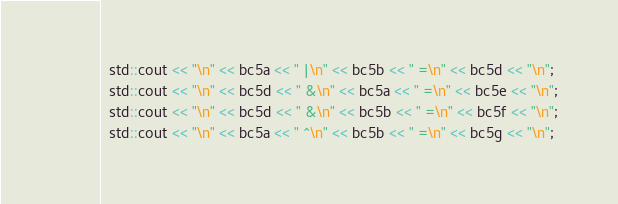Convert code to text. <code><loc_0><loc_0><loc_500><loc_500><_C++_>  std::cout << "\n" << bc5a << " |\n" << bc5b << " =\n" << bc5d << "\n";
  std::cout << "\n" << bc5d << " &\n" << bc5a << " =\n" << bc5e << "\n";
  std::cout << "\n" << bc5d << " &\n" << bc5b << " =\n" << bc5f << "\n";
  std::cout << "\n" << bc5a << " ^\n" << bc5b << " =\n" << bc5g << "\n";</code> 